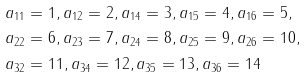Convert formula to latex. <formula><loc_0><loc_0><loc_500><loc_500>a _ { 1 1 } & = 1 , a _ { 1 2 } = 2 , a _ { 1 4 } = 3 , a _ { 1 5 } = 4 , a _ { 1 6 } = 5 , \\ a _ { 2 2 } & = 6 , a _ { 2 3 } = 7 , a _ { 2 4 } = 8 , a _ { 2 5 } = 9 , a _ { 2 6 } = 1 0 , \\ a _ { 3 2 } & = 1 1 , a _ { 3 4 } = 1 2 , a _ { 3 5 } = 1 3 , a _ { 3 6 } = 1 4</formula> 